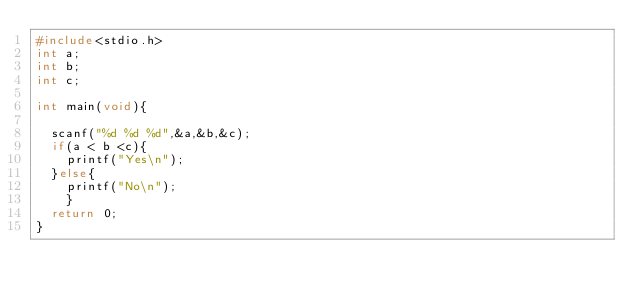<code> <loc_0><loc_0><loc_500><loc_500><_C_>#include<stdio.h>
int a;
int b;
int c;

int main(void){

	scanf("%d %d %d",&a,&b,&c);
	if(a < b <c){
		printf("Yes\n");
	}else{
		printf("No\n");
		}
	return 0;
}</code> 